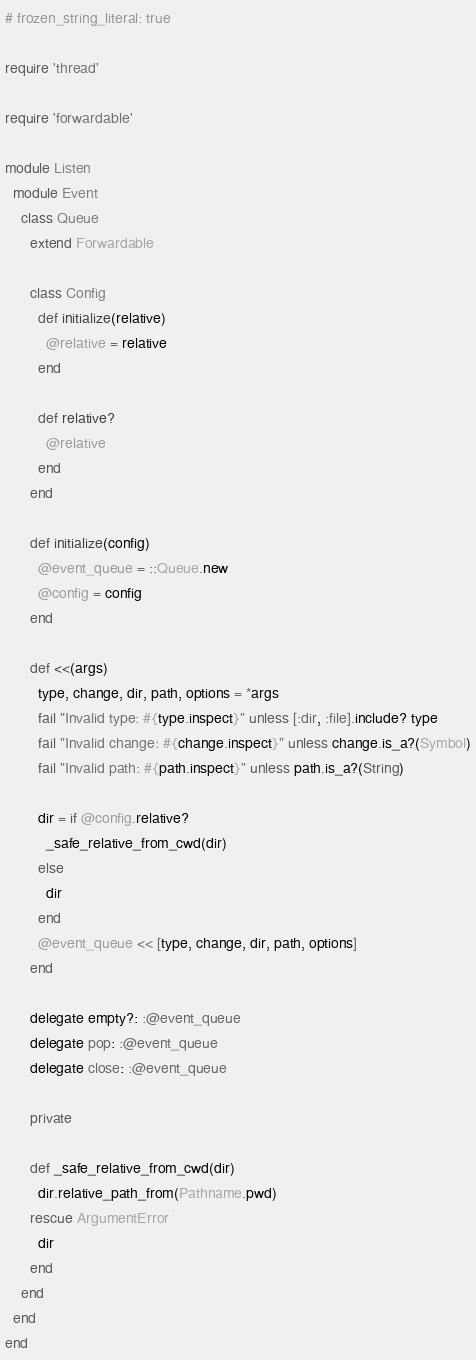Convert code to text. <code><loc_0><loc_0><loc_500><loc_500><_Ruby_># frozen_string_literal: true

require 'thread'

require 'forwardable'

module Listen
  module Event
    class Queue
      extend Forwardable

      class Config
        def initialize(relative)
          @relative = relative
        end

        def relative?
          @relative
        end
      end

      def initialize(config)
        @event_queue = ::Queue.new
        @config = config
      end

      def <<(args)
        type, change, dir, path, options = *args
        fail "Invalid type: #{type.inspect}" unless [:dir, :file].include? type
        fail "Invalid change: #{change.inspect}" unless change.is_a?(Symbol)
        fail "Invalid path: #{path.inspect}" unless path.is_a?(String)

        dir = if @config.relative?
          _safe_relative_from_cwd(dir)
        else
          dir
        end
        @event_queue << [type, change, dir, path, options]
      end

      delegate empty?: :@event_queue
      delegate pop: :@event_queue
      delegate close: :@event_queue

      private

      def _safe_relative_from_cwd(dir)
        dir.relative_path_from(Pathname.pwd)
      rescue ArgumentError
        dir
      end
    end
  end
end
</code> 